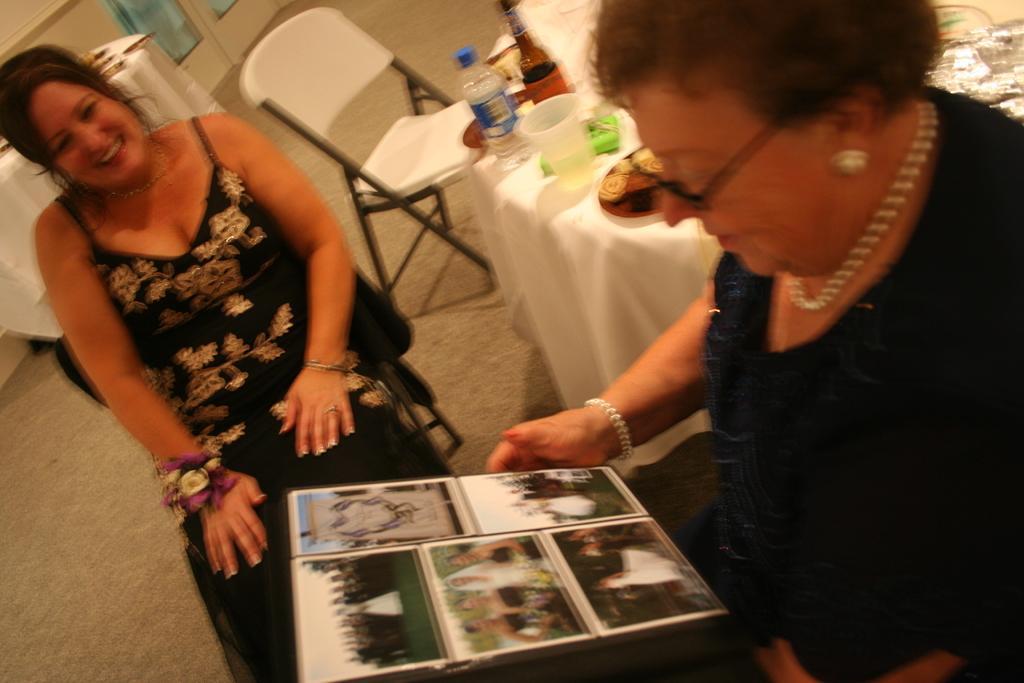Could you give a brief overview of what you see in this image? These two persons sitting on the chair. This person holding frame. There is a table. On the table we can see bottle,glass,cloth. we can see chair. This is floor. On the background we can see wall. 